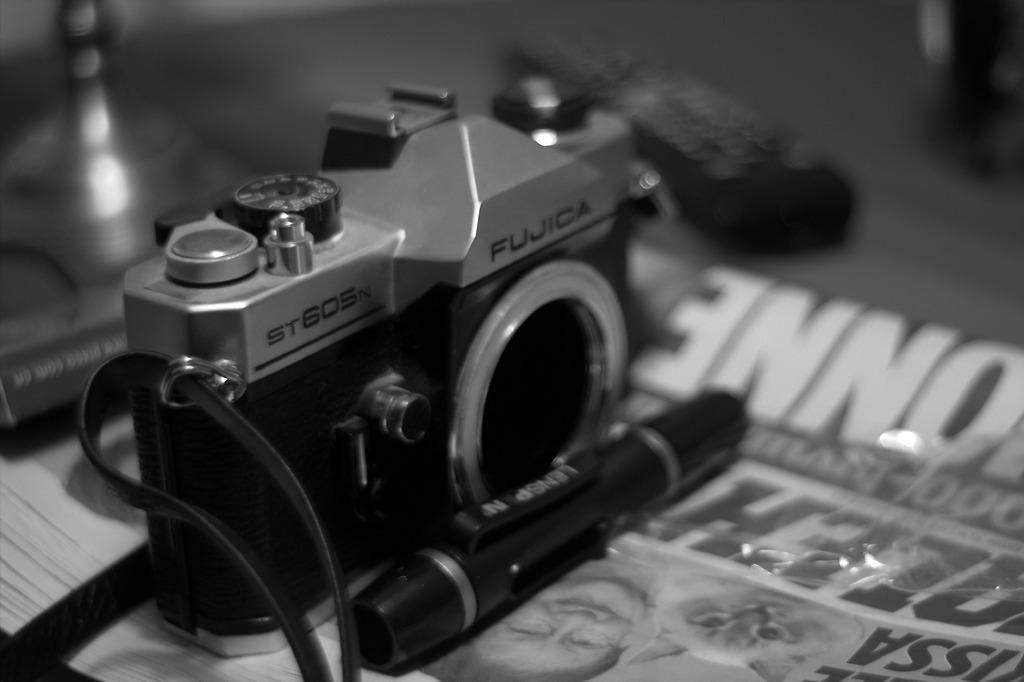Describe this image in one or two sentences. In this image there is a camera and a pen are on the newspaper. Left side there is a book. Background is blurry. 